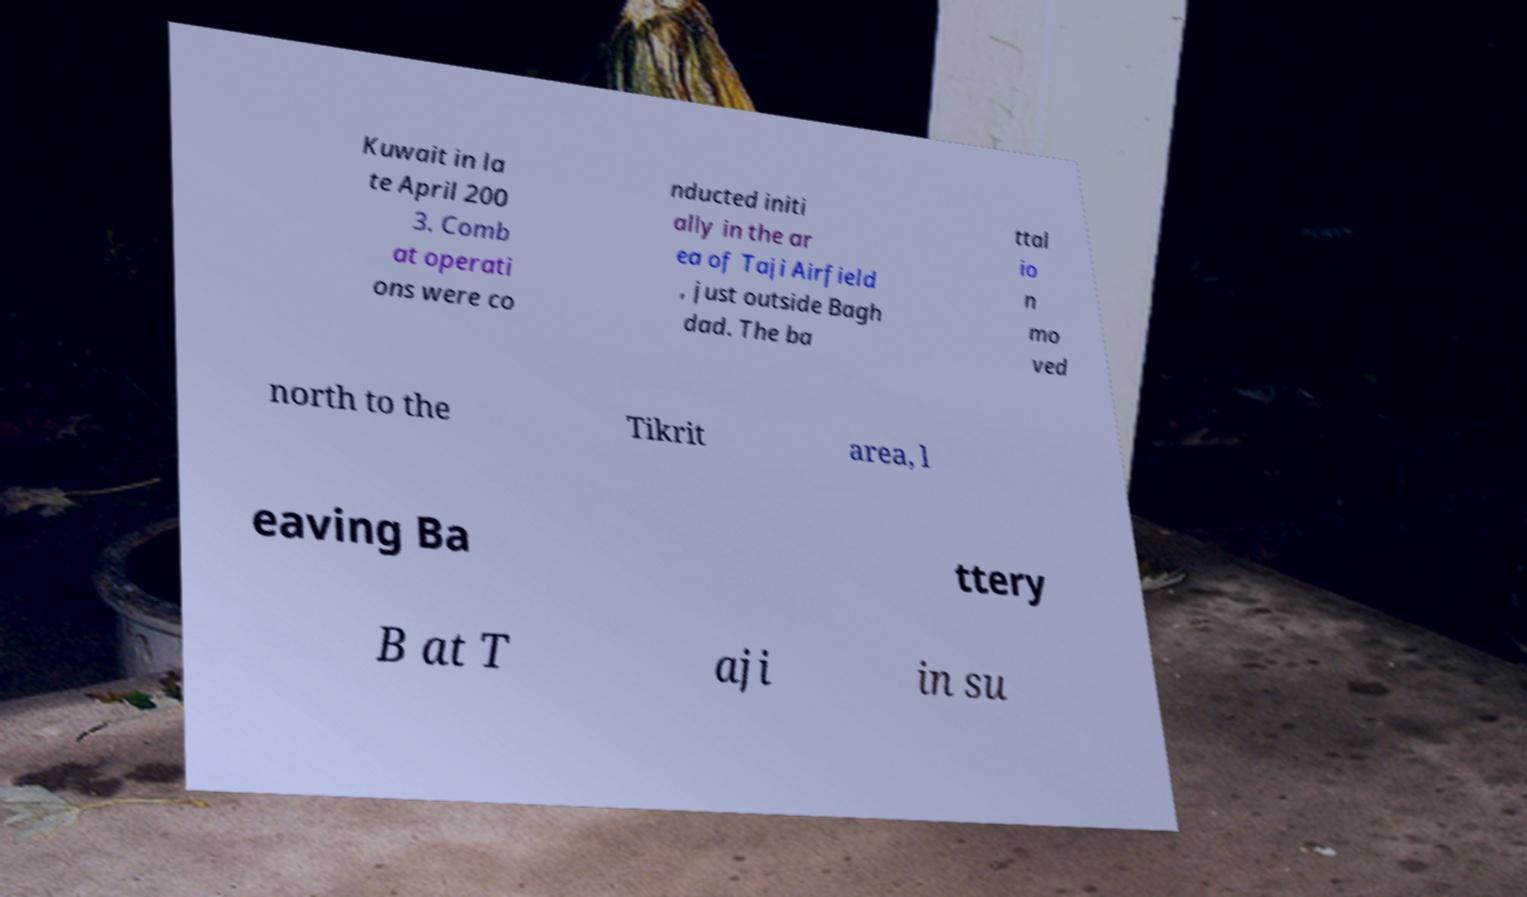Please identify and transcribe the text found in this image. Kuwait in la te April 200 3. Comb at operati ons were co nducted initi ally in the ar ea of Taji Airfield , just outside Bagh dad. The ba ttal io n mo ved north to the Tikrit area, l eaving Ba ttery B at T aji in su 